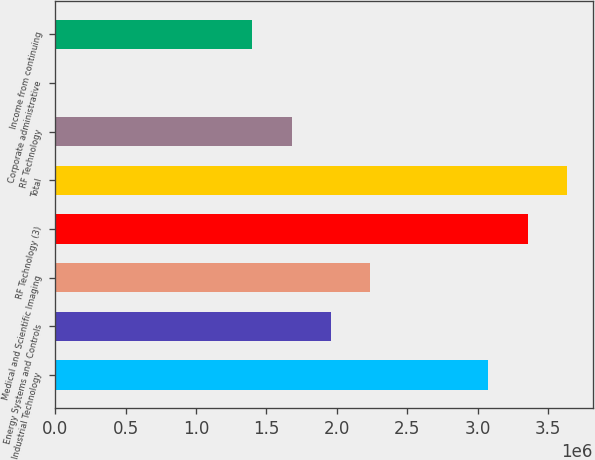Convert chart to OTSL. <chart><loc_0><loc_0><loc_500><loc_500><bar_chart><fcel>Industrial Technology<fcel>Energy Systems and Controls<fcel>Medical and Scientific Imaging<fcel>RF Technology (3)<fcel>Total<fcel>RF Technology<fcel>Corporate administrative<fcel>Income from continuing<nl><fcel>3.0768e+06<fcel>1.95796e+06<fcel>2.23767e+06<fcel>3.35651e+06<fcel>3.63622e+06<fcel>1.67825e+06<fcel>2<fcel>1.39855e+06<nl></chart> 